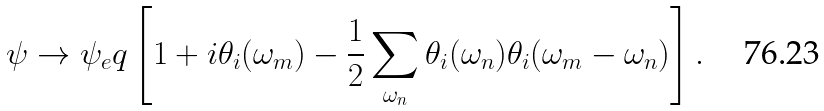Convert formula to latex. <formula><loc_0><loc_0><loc_500><loc_500>\psi \rightarrow \psi _ { e } q \left [ 1 + i \theta _ { i } ( \omega _ { m } ) - \frac { 1 } { 2 } \sum _ { \omega _ { n } } \theta _ { i } ( \omega _ { n } ) \theta _ { i } ( \omega _ { m } - \omega _ { n } ) \right ] .</formula> 